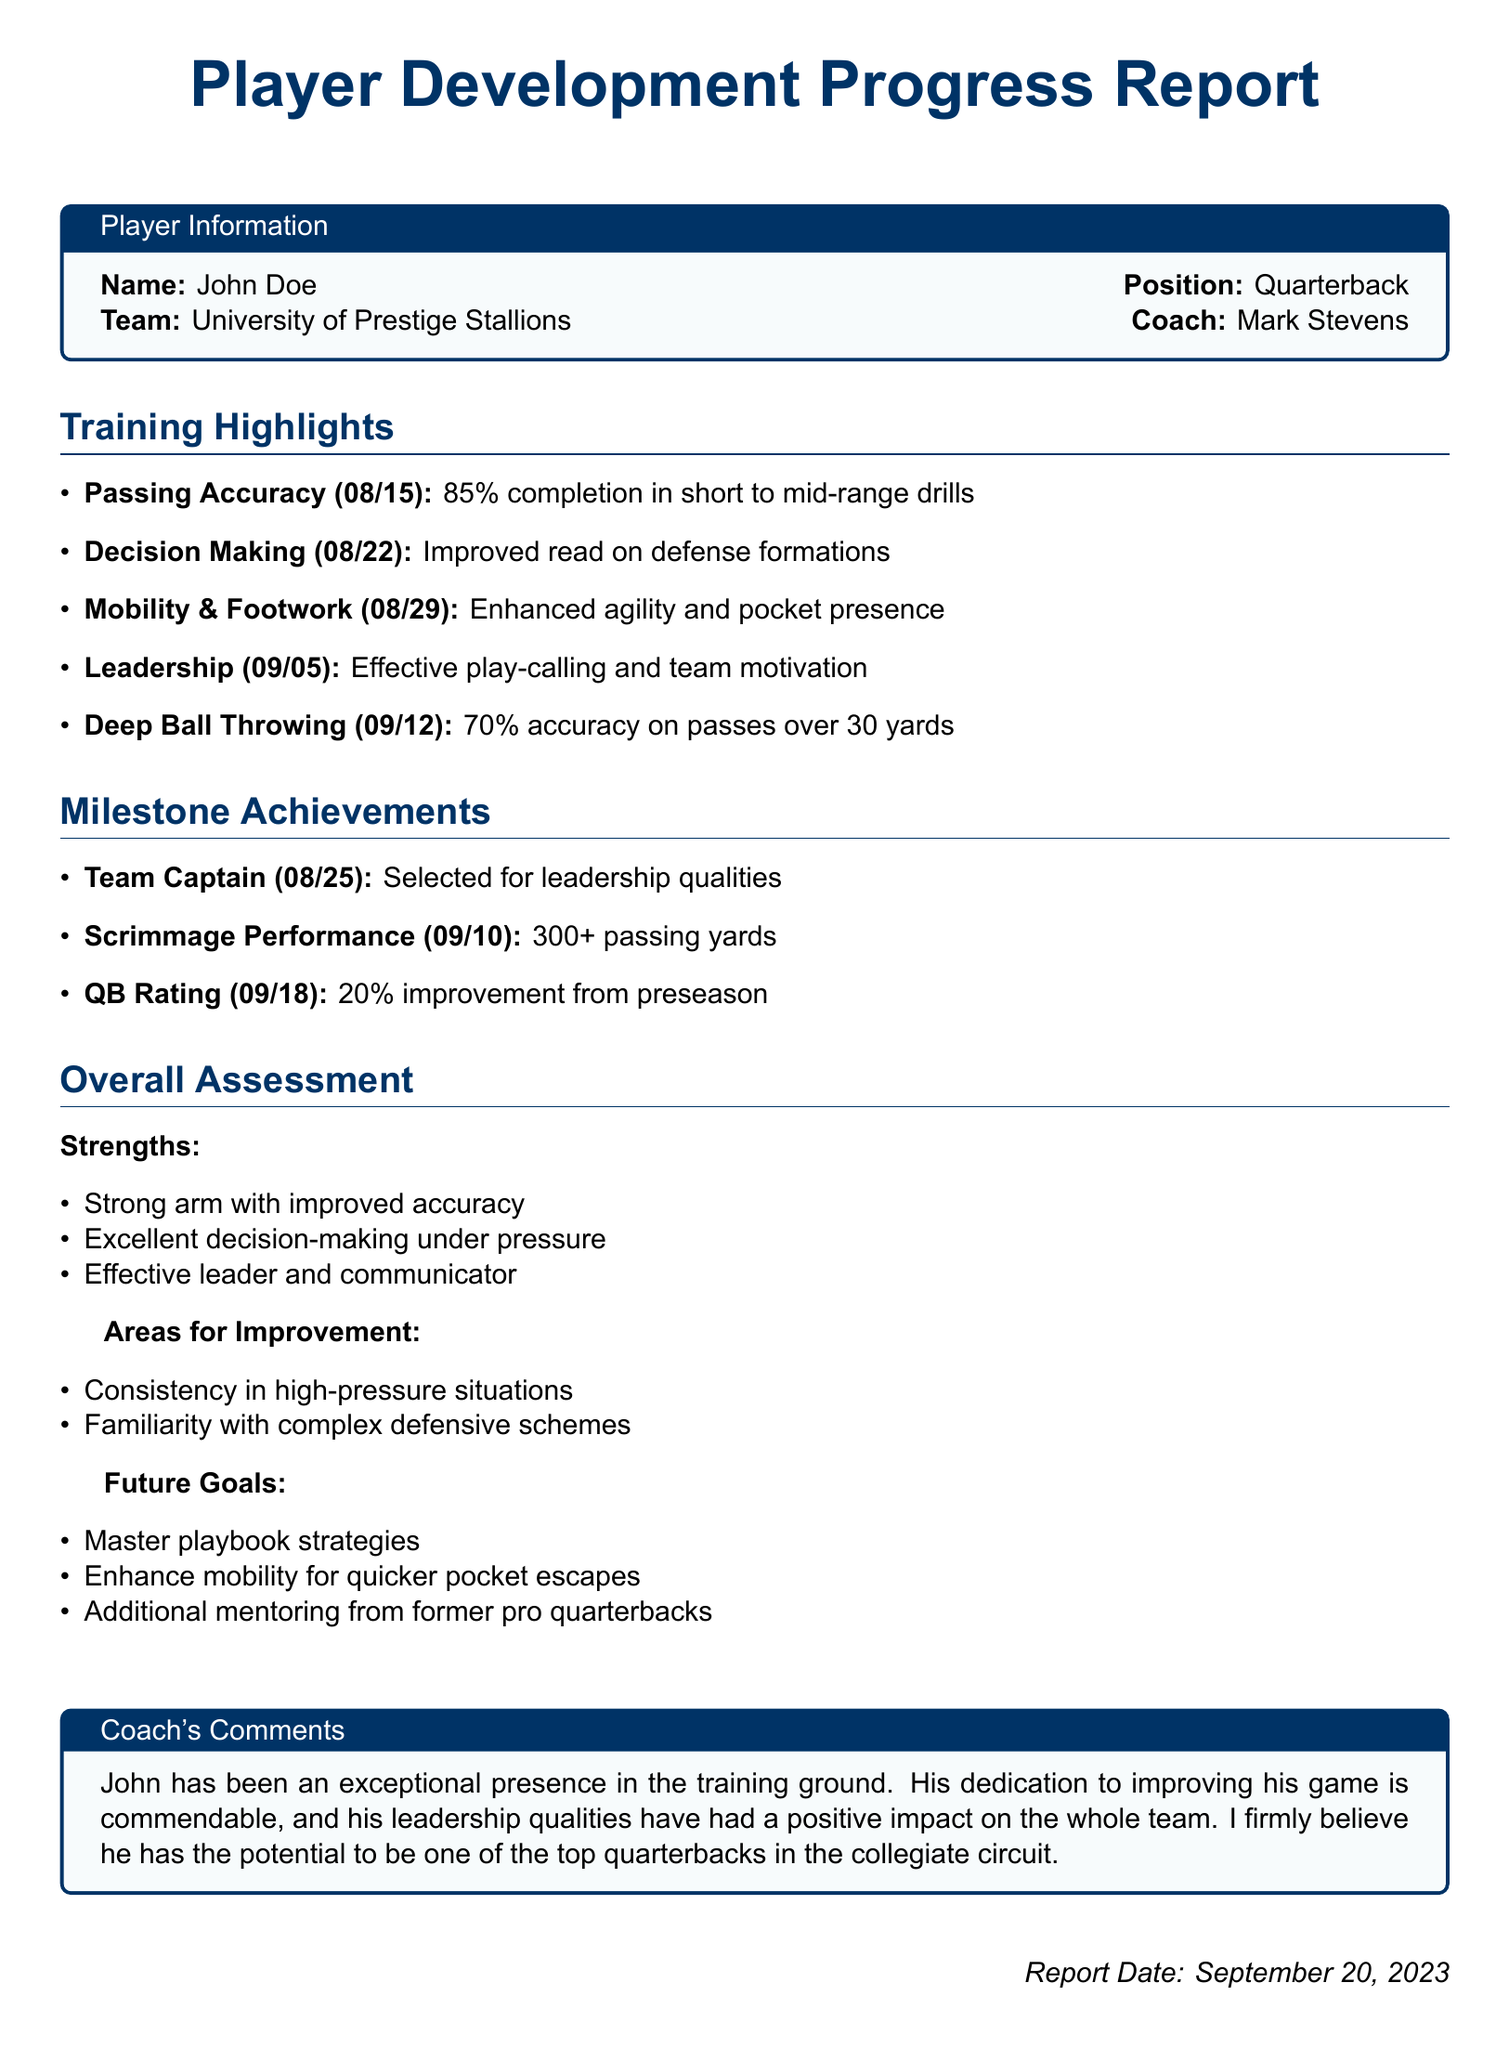What is the player's name? The document presents player information, including the name, which is John Doe.
Answer: John Doe What position does John Doe play? The player's position is stated in the document as quarterback.
Answer: Quarterback What percentage of passing accuracy was achieved on 08/15? The report lists passing accuracy on that date, which is 85 percent.
Answer: 85% On what date was John selected as Team Captain? The document specifies that the Team Captain was selected on August 25.
Answer: 08/25 How many passing yards did John achieve in the scrimmage performance? The milestone achievements mention John's performance includes 300 or more passing yards.
Answer: 300+ What is one of John's strengths mentioned in the overall assessment? The strengths section identifies strong arm with improved accuracy as a key quality.
Answer: Strong arm What area does the report suggest John needs to improve upon? The document lists areas for improvement, including consistency in high-pressure situations.
Answer: Consistency What is the report date? The document provides the report date at the bottom, which is September 20, 2023.
Answer: September 20, 2023 What is one of John's future goals outlined in the document? The future goals section mentions mastering playbook strategies as one of his targets.
Answer: Master playbook strategies 